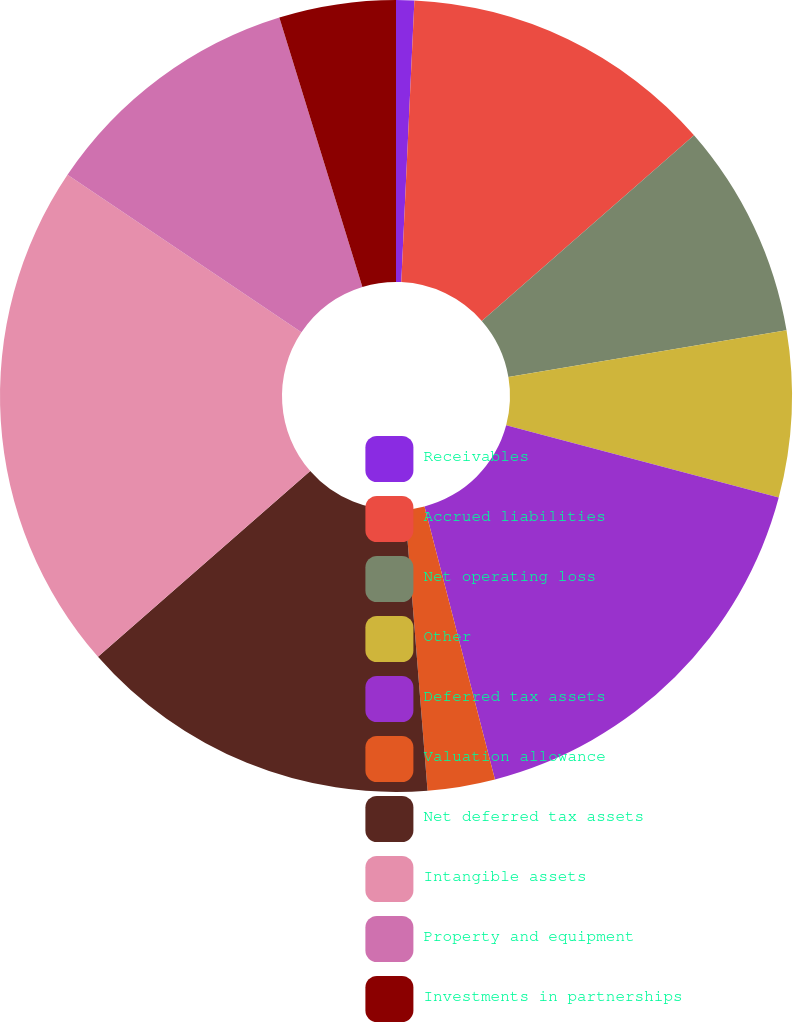Convert chart to OTSL. <chart><loc_0><loc_0><loc_500><loc_500><pie_chart><fcel>Receivables<fcel>Accrued liabilities<fcel>Net operating loss<fcel>Other<fcel>Deferred tax assets<fcel>Valuation allowance<fcel>Net deferred tax assets<fcel>Intangible assets<fcel>Property and equipment<fcel>Investments in partnerships<nl><fcel>0.74%<fcel>12.82%<fcel>8.79%<fcel>6.78%<fcel>16.85%<fcel>2.75%<fcel>14.83%<fcel>20.87%<fcel>10.81%<fcel>4.76%<nl></chart> 